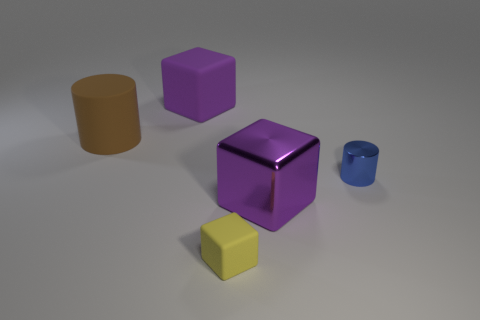Is there anything else that has the same size as the brown rubber cylinder?
Provide a succinct answer. Yes. There is a block that is made of the same material as the blue thing; what is its color?
Your answer should be very brief. Purple. Do the large brown rubber object and the tiny blue metallic thing have the same shape?
Ensure brevity in your answer.  Yes. How many things are on the right side of the big brown cylinder and in front of the large purple rubber cube?
Keep it short and to the point. 3. How many rubber things are either brown objects or brown spheres?
Your response must be concise. 1. What size is the thing to the right of the metallic object that is left of the small blue thing?
Your answer should be very brief. Small. What is the material of the big thing that is the same color as the metallic cube?
Give a very brief answer. Rubber. Is there a large purple metal block that is left of the big purple object that is right of the large purple object left of the tiny yellow matte object?
Your response must be concise. No. Are the large purple cube that is in front of the small blue metal thing and the cylinder on the right side of the big purple rubber thing made of the same material?
Your response must be concise. Yes. How many objects are brown rubber objects or purple blocks in front of the big rubber block?
Give a very brief answer. 2. 